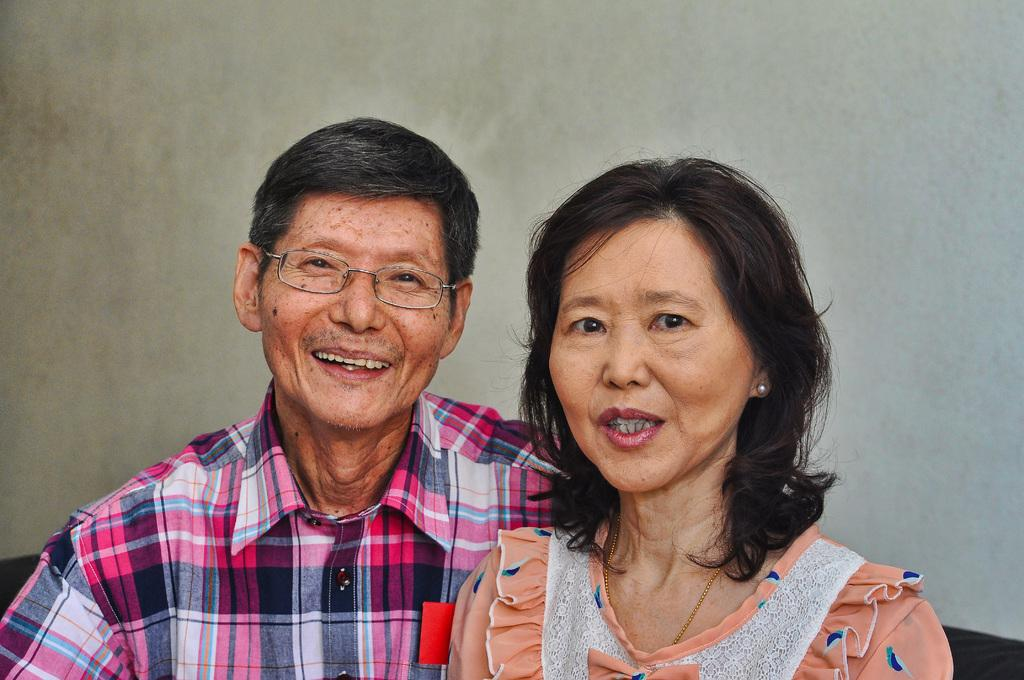Who are the people in the image? There is a woman and a man in the image. What are the woman and the man doing in the image? Both the woman and the man are watching something and smiling. What can be seen in the background of the image? There is a wall in the background of the image. What theory does the actor in the image propose? There is no actor present in the image, and therefore no theory can be proposed. What attraction can be seen in the background of the image? The background of the image only shows a wall, and there is no attraction visible. 